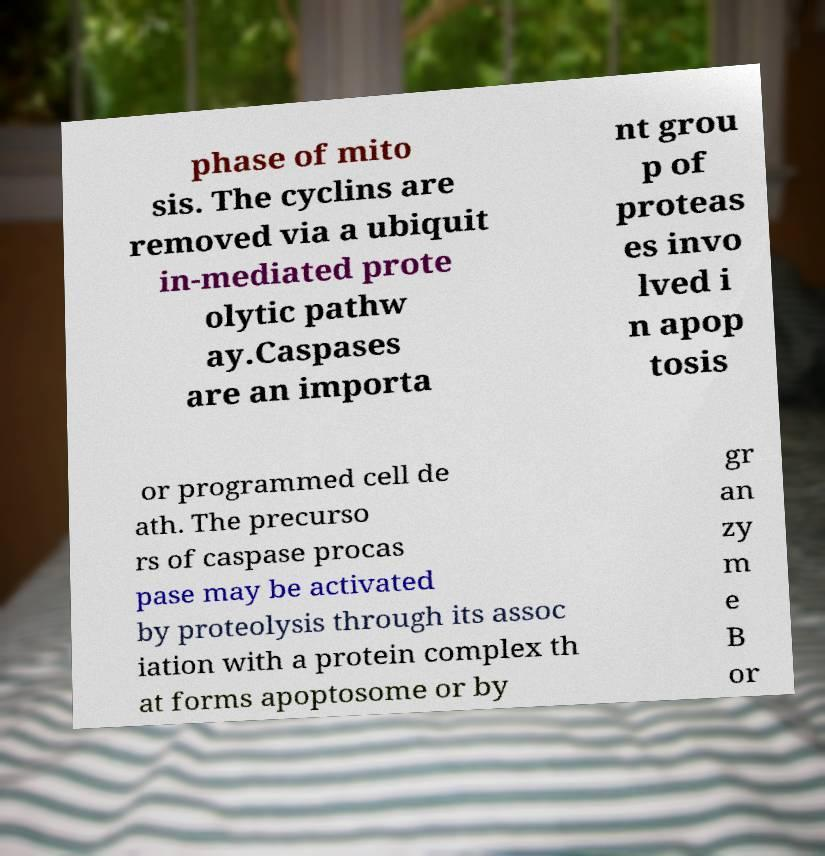Please read and relay the text visible in this image. What does it say? phase of mito sis. The cyclins are removed via a ubiquit in-mediated prote olytic pathw ay.Caspases are an importa nt grou p of proteas es invo lved i n apop tosis or programmed cell de ath. The precurso rs of caspase procas pase may be activated by proteolysis through its assoc iation with a protein complex th at forms apoptosome or by gr an zy m e B or 